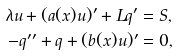<formula> <loc_0><loc_0><loc_500><loc_500>\lambda u + ( a ( x ) u ) ^ { \prime } + L q ^ { \prime } & = S , \\ - q ^ { \prime \prime } + q + ( b ( x ) u ) ^ { \prime } & = 0 ,</formula> 